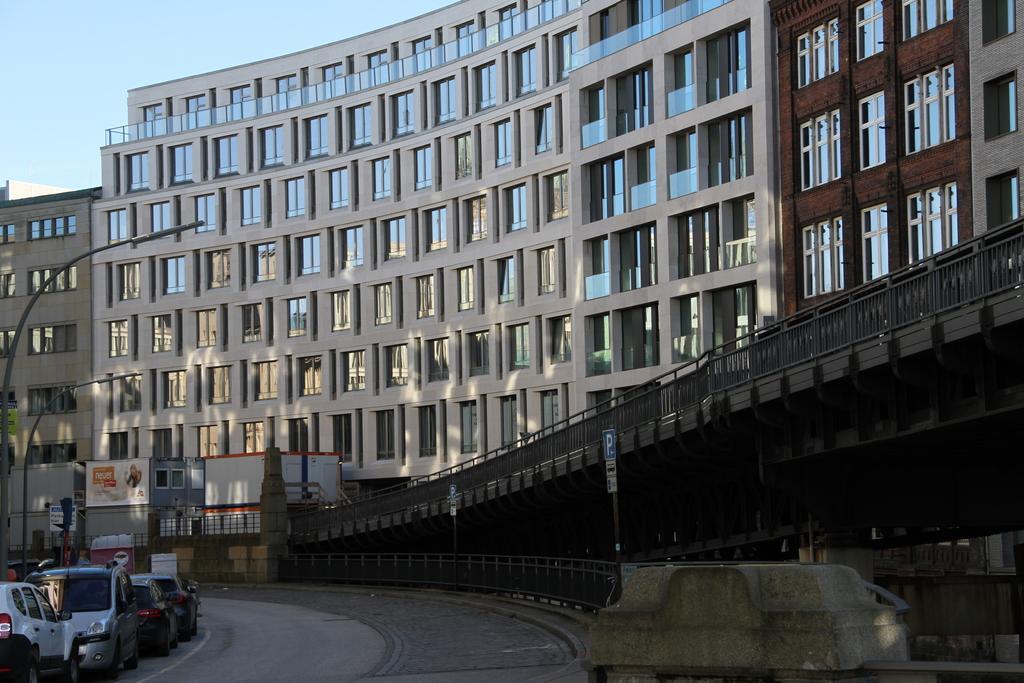In one or two sentences, can you explain what this image depicts? In this image I can see a road in the front and on the right side of it I can see few sign boards. On the left side of the road I can few vehicles, few poles, few street lights and one more board. In the background I can see few buildings and the sky. 